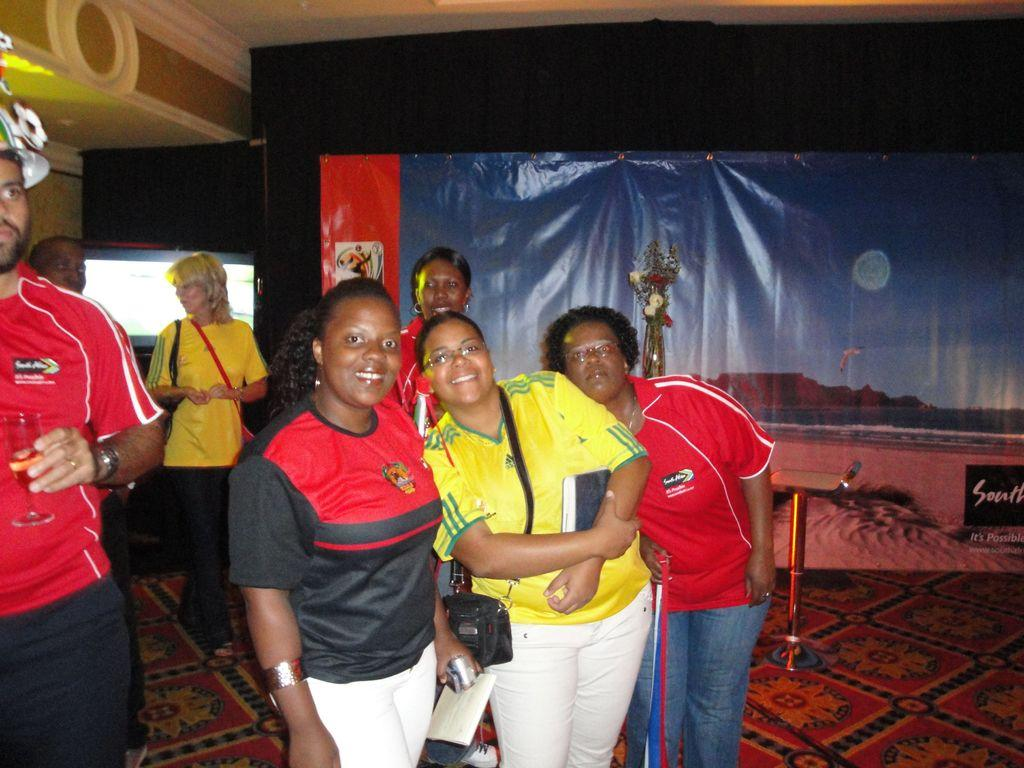How many people are in the group that is visible in the image? There is a group of people in the image, but the exact number is not specified. What are the three people who are standing doing? The three people who are standing are smiling. What object can be seen in the image that might be used for carrying items? There is a bag in the image that could be used for carrying items. What type of paper is visible in the image? There is a paper in the image, but its content or type is not specified. What is the pole on the floor in the image used for? The purpose of the pole on the floor in the image is not specified. What is written on the banner in the image? The content of the banner in the image is not specified. What can be seen in the background of the image? There is a screen visible in the background of the image. What type of boot is being worn by the person on the left side of the image? There is no person wearing a boot in the image. What season is it in the image, given the presence of a plantation? There is no plantation present in the image, and therefore no indication of the season. 